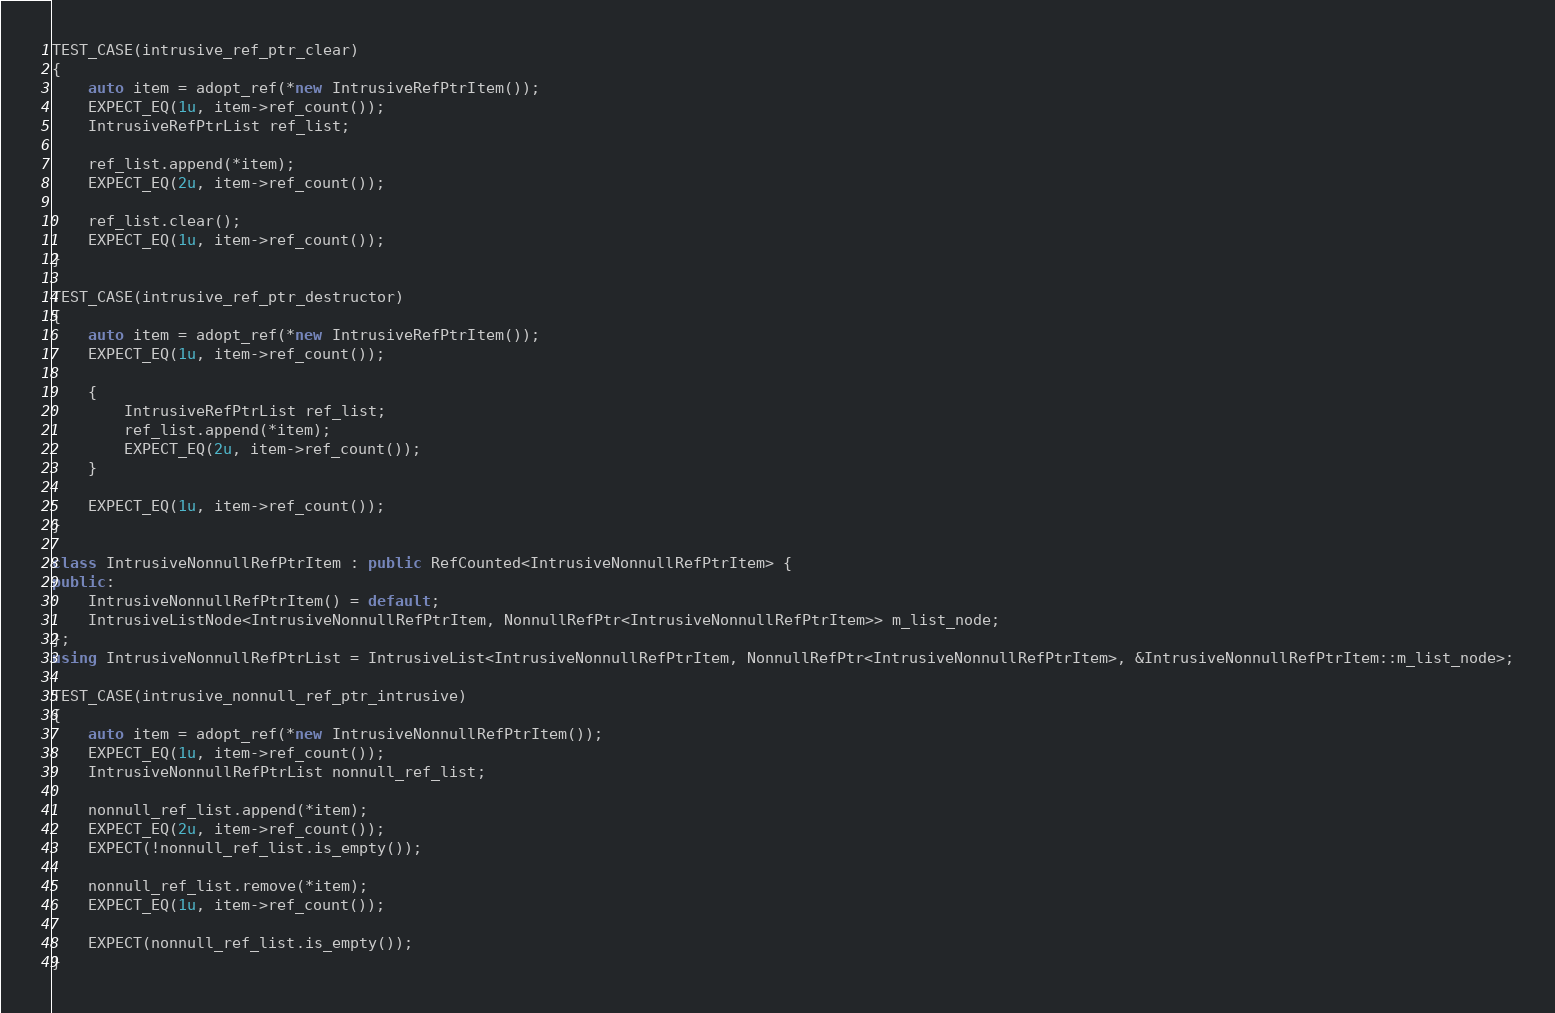Convert code to text. <code><loc_0><loc_0><loc_500><loc_500><_C++_>TEST_CASE(intrusive_ref_ptr_clear)
{
    auto item = adopt_ref(*new IntrusiveRefPtrItem());
    EXPECT_EQ(1u, item->ref_count());
    IntrusiveRefPtrList ref_list;

    ref_list.append(*item);
    EXPECT_EQ(2u, item->ref_count());

    ref_list.clear();
    EXPECT_EQ(1u, item->ref_count());
}

TEST_CASE(intrusive_ref_ptr_destructor)
{
    auto item = adopt_ref(*new IntrusiveRefPtrItem());
    EXPECT_EQ(1u, item->ref_count());

    {
        IntrusiveRefPtrList ref_list;
        ref_list.append(*item);
        EXPECT_EQ(2u, item->ref_count());
    }

    EXPECT_EQ(1u, item->ref_count());
}

class IntrusiveNonnullRefPtrItem : public RefCounted<IntrusiveNonnullRefPtrItem> {
public:
    IntrusiveNonnullRefPtrItem() = default;
    IntrusiveListNode<IntrusiveNonnullRefPtrItem, NonnullRefPtr<IntrusiveNonnullRefPtrItem>> m_list_node;
};
using IntrusiveNonnullRefPtrList = IntrusiveList<IntrusiveNonnullRefPtrItem, NonnullRefPtr<IntrusiveNonnullRefPtrItem>, &IntrusiveNonnullRefPtrItem::m_list_node>;

TEST_CASE(intrusive_nonnull_ref_ptr_intrusive)
{
    auto item = adopt_ref(*new IntrusiveNonnullRefPtrItem());
    EXPECT_EQ(1u, item->ref_count());
    IntrusiveNonnullRefPtrList nonnull_ref_list;

    nonnull_ref_list.append(*item);
    EXPECT_EQ(2u, item->ref_count());
    EXPECT(!nonnull_ref_list.is_empty());

    nonnull_ref_list.remove(*item);
    EXPECT_EQ(1u, item->ref_count());

    EXPECT(nonnull_ref_list.is_empty());
}
</code> 